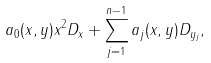<formula> <loc_0><loc_0><loc_500><loc_500>a _ { 0 } ( x , y ) x ^ { 2 } D _ { x } + \sum _ { j = 1 } ^ { n - 1 } a _ { j } ( x , y ) D _ { y _ { j } } ,</formula> 